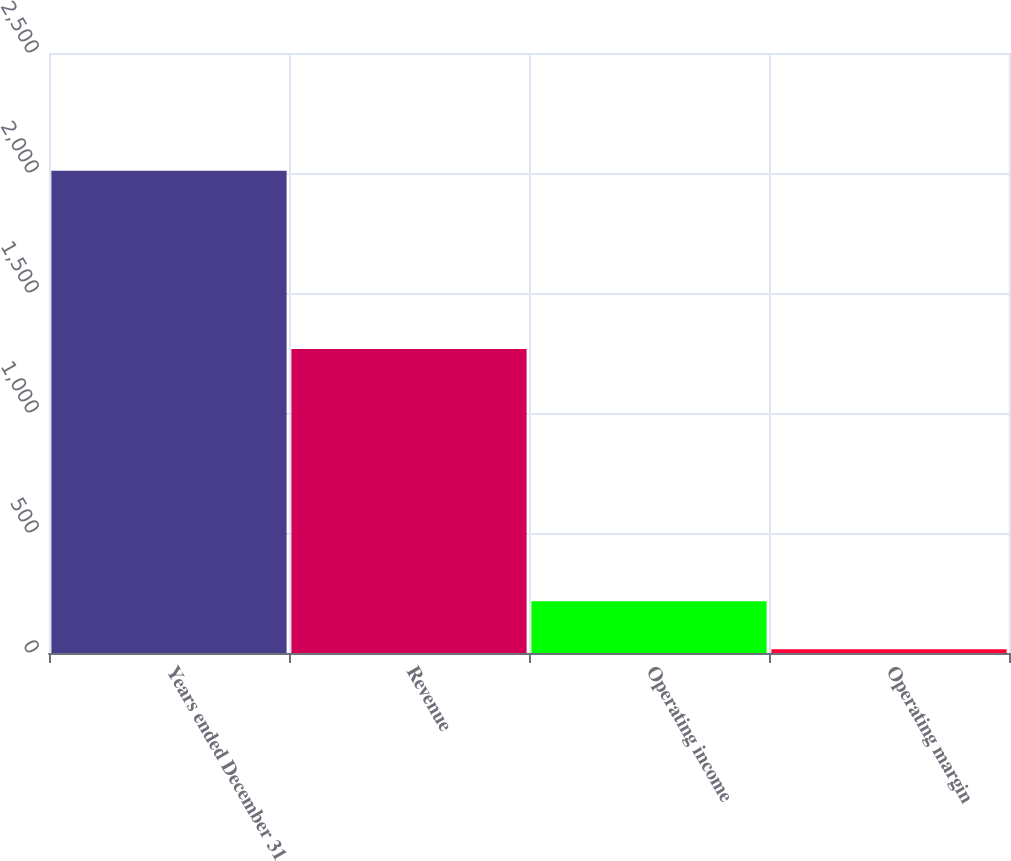Convert chart to OTSL. <chart><loc_0><loc_0><loc_500><loc_500><bar_chart><fcel>Years ended December 31<fcel>Revenue<fcel>Operating income<fcel>Operating margin<nl><fcel>2009<fcel>1267<fcel>215.3<fcel>16<nl></chart> 